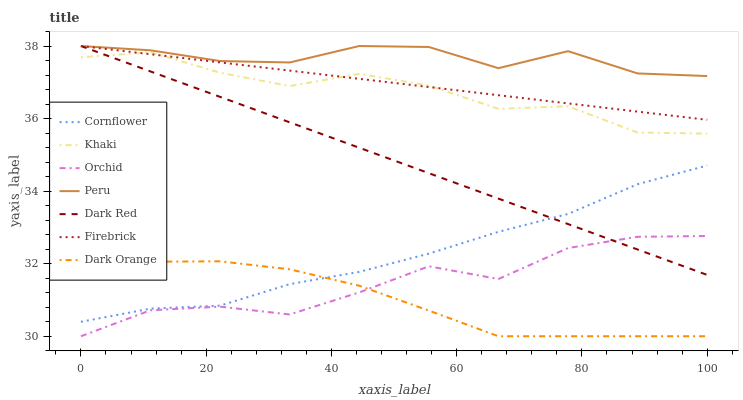Does Dark Orange have the minimum area under the curve?
Answer yes or no. Yes. Does Peru have the maximum area under the curve?
Answer yes or no. Yes. Does Khaki have the minimum area under the curve?
Answer yes or no. No. Does Khaki have the maximum area under the curve?
Answer yes or no. No. Is Firebrick the smoothest?
Answer yes or no. Yes. Is Orchid the roughest?
Answer yes or no. Yes. Is Khaki the smoothest?
Answer yes or no. No. Is Khaki the roughest?
Answer yes or no. No. Does Dark Orange have the lowest value?
Answer yes or no. Yes. Does Khaki have the lowest value?
Answer yes or no. No. Does Peru have the highest value?
Answer yes or no. Yes. Does Khaki have the highest value?
Answer yes or no. No. Is Orchid less than Firebrick?
Answer yes or no. Yes. Is Firebrick greater than Orchid?
Answer yes or no. Yes. Does Cornflower intersect Dark Orange?
Answer yes or no. Yes. Is Cornflower less than Dark Orange?
Answer yes or no. No. Is Cornflower greater than Dark Orange?
Answer yes or no. No. Does Orchid intersect Firebrick?
Answer yes or no. No. 